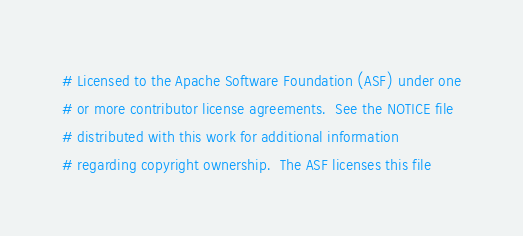<code> <loc_0><loc_0><loc_500><loc_500><_Cython_># Licensed to the Apache Software Foundation (ASF) under one
# or more contributor license agreements.  See the NOTICE file
# distributed with this work for additional information
# regarding copyright ownership.  The ASF licenses this file</code> 